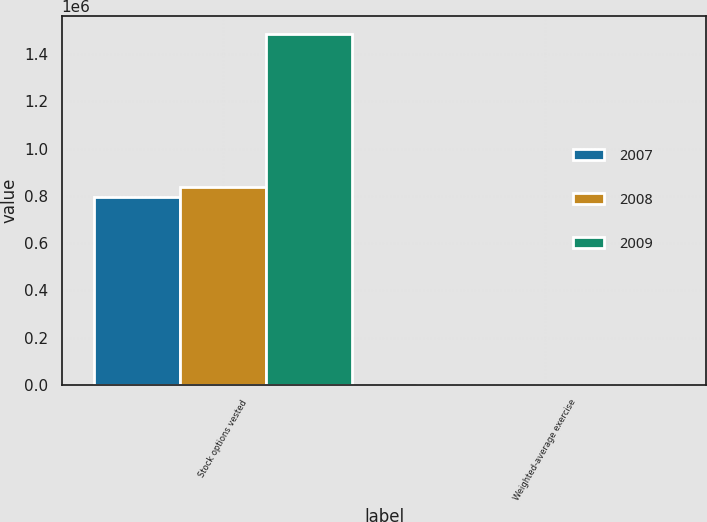<chart> <loc_0><loc_0><loc_500><loc_500><stacked_bar_chart><ecel><fcel>Stock options vested<fcel>Weighted-average exercise<nl><fcel>2007<fcel>795566<fcel>46.86<nl><fcel>2008<fcel>835982<fcel>47.21<nl><fcel>2009<fcel>1.48473e+06<fcel>47.05<nl></chart> 